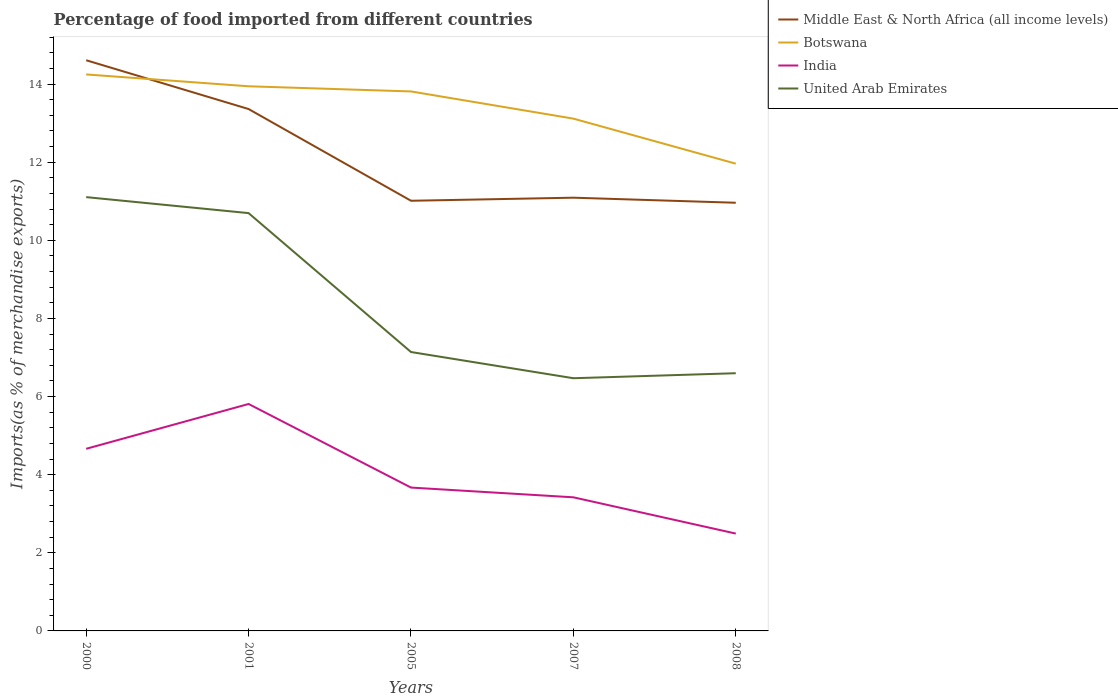How many different coloured lines are there?
Give a very brief answer. 4. Is the number of lines equal to the number of legend labels?
Keep it short and to the point. Yes. Across all years, what is the maximum percentage of imports to different countries in Middle East & North Africa (all income levels)?
Provide a short and direct response. 10.96. What is the total percentage of imports to different countries in Middle East & North Africa (all income levels) in the graph?
Ensure brevity in your answer.  1.25. What is the difference between the highest and the second highest percentage of imports to different countries in Middle East & North Africa (all income levels)?
Make the answer very short. 3.65. Is the percentage of imports to different countries in India strictly greater than the percentage of imports to different countries in Middle East & North Africa (all income levels) over the years?
Provide a succinct answer. Yes. How many years are there in the graph?
Keep it short and to the point. 5. What is the difference between two consecutive major ticks on the Y-axis?
Give a very brief answer. 2. Are the values on the major ticks of Y-axis written in scientific E-notation?
Your answer should be compact. No. Does the graph contain any zero values?
Give a very brief answer. No. Where does the legend appear in the graph?
Your response must be concise. Top right. What is the title of the graph?
Keep it short and to the point. Percentage of food imported from different countries. What is the label or title of the X-axis?
Your answer should be very brief. Years. What is the label or title of the Y-axis?
Make the answer very short. Imports(as % of merchandise exports). What is the Imports(as % of merchandise exports) in Middle East & North Africa (all income levels) in 2000?
Your answer should be compact. 14.61. What is the Imports(as % of merchandise exports) of Botswana in 2000?
Your answer should be very brief. 14.25. What is the Imports(as % of merchandise exports) of India in 2000?
Make the answer very short. 4.66. What is the Imports(as % of merchandise exports) of United Arab Emirates in 2000?
Your response must be concise. 11.11. What is the Imports(as % of merchandise exports) of Middle East & North Africa (all income levels) in 2001?
Ensure brevity in your answer.  13.36. What is the Imports(as % of merchandise exports) in Botswana in 2001?
Keep it short and to the point. 13.94. What is the Imports(as % of merchandise exports) in India in 2001?
Your answer should be very brief. 5.81. What is the Imports(as % of merchandise exports) in United Arab Emirates in 2001?
Provide a short and direct response. 10.7. What is the Imports(as % of merchandise exports) of Middle East & North Africa (all income levels) in 2005?
Make the answer very short. 11.01. What is the Imports(as % of merchandise exports) of Botswana in 2005?
Keep it short and to the point. 13.81. What is the Imports(as % of merchandise exports) in India in 2005?
Make the answer very short. 3.67. What is the Imports(as % of merchandise exports) in United Arab Emirates in 2005?
Your answer should be compact. 7.14. What is the Imports(as % of merchandise exports) in Middle East & North Africa (all income levels) in 2007?
Your answer should be very brief. 11.09. What is the Imports(as % of merchandise exports) in Botswana in 2007?
Keep it short and to the point. 13.12. What is the Imports(as % of merchandise exports) of India in 2007?
Make the answer very short. 3.42. What is the Imports(as % of merchandise exports) in United Arab Emirates in 2007?
Offer a terse response. 6.47. What is the Imports(as % of merchandise exports) in Middle East & North Africa (all income levels) in 2008?
Provide a succinct answer. 10.96. What is the Imports(as % of merchandise exports) of Botswana in 2008?
Make the answer very short. 11.96. What is the Imports(as % of merchandise exports) in India in 2008?
Ensure brevity in your answer.  2.49. What is the Imports(as % of merchandise exports) of United Arab Emirates in 2008?
Give a very brief answer. 6.6. Across all years, what is the maximum Imports(as % of merchandise exports) of Middle East & North Africa (all income levels)?
Your answer should be very brief. 14.61. Across all years, what is the maximum Imports(as % of merchandise exports) of Botswana?
Provide a succinct answer. 14.25. Across all years, what is the maximum Imports(as % of merchandise exports) of India?
Your answer should be very brief. 5.81. Across all years, what is the maximum Imports(as % of merchandise exports) of United Arab Emirates?
Your answer should be very brief. 11.11. Across all years, what is the minimum Imports(as % of merchandise exports) in Middle East & North Africa (all income levels)?
Your answer should be very brief. 10.96. Across all years, what is the minimum Imports(as % of merchandise exports) in Botswana?
Offer a very short reply. 11.96. Across all years, what is the minimum Imports(as % of merchandise exports) of India?
Ensure brevity in your answer.  2.49. Across all years, what is the minimum Imports(as % of merchandise exports) of United Arab Emirates?
Your answer should be compact. 6.47. What is the total Imports(as % of merchandise exports) of Middle East & North Africa (all income levels) in the graph?
Provide a succinct answer. 61.04. What is the total Imports(as % of merchandise exports) in Botswana in the graph?
Your answer should be compact. 67.08. What is the total Imports(as % of merchandise exports) in India in the graph?
Provide a succinct answer. 20.06. What is the total Imports(as % of merchandise exports) of United Arab Emirates in the graph?
Give a very brief answer. 42.01. What is the difference between the Imports(as % of merchandise exports) in Middle East & North Africa (all income levels) in 2000 and that in 2001?
Ensure brevity in your answer.  1.25. What is the difference between the Imports(as % of merchandise exports) of Botswana in 2000 and that in 2001?
Keep it short and to the point. 0.3. What is the difference between the Imports(as % of merchandise exports) of India in 2000 and that in 2001?
Offer a very short reply. -1.15. What is the difference between the Imports(as % of merchandise exports) in United Arab Emirates in 2000 and that in 2001?
Keep it short and to the point. 0.41. What is the difference between the Imports(as % of merchandise exports) in Middle East & North Africa (all income levels) in 2000 and that in 2005?
Offer a terse response. 3.6. What is the difference between the Imports(as % of merchandise exports) of Botswana in 2000 and that in 2005?
Provide a short and direct response. 0.44. What is the difference between the Imports(as % of merchandise exports) of India in 2000 and that in 2005?
Provide a succinct answer. 0.99. What is the difference between the Imports(as % of merchandise exports) in United Arab Emirates in 2000 and that in 2005?
Keep it short and to the point. 3.97. What is the difference between the Imports(as % of merchandise exports) of Middle East & North Africa (all income levels) in 2000 and that in 2007?
Your response must be concise. 3.52. What is the difference between the Imports(as % of merchandise exports) in Botswana in 2000 and that in 2007?
Your answer should be very brief. 1.13. What is the difference between the Imports(as % of merchandise exports) in India in 2000 and that in 2007?
Give a very brief answer. 1.24. What is the difference between the Imports(as % of merchandise exports) in United Arab Emirates in 2000 and that in 2007?
Give a very brief answer. 4.64. What is the difference between the Imports(as % of merchandise exports) in Middle East & North Africa (all income levels) in 2000 and that in 2008?
Offer a terse response. 3.65. What is the difference between the Imports(as % of merchandise exports) of Botswana in 2000 and that in 2008?
Your answer should be compact. 2.28. What is the difference between the Imports(as % of merchandise exports) in India in 2000 and that in 2008?
Your answer should be very brief. 2.17. What is the difference between the Imports(as % of merchandise exports) in United Arab Emirates in 2000 and that in 2008?
Offer a very short reply. 4.51. What is the difference between the Imports(as % of merchandise exports) of Middle East & North Africa (all income levels) in 2001 and that in 2005?
Keep it short and to the point. 2.35. What is the difference between the Imports(as % of merchandise exports) of Botswana in 2001 and that in 2005?
Give a very brief answer. 0.13. What is the difference between the Imports(as % of merchandise exports) of India in 2001 and that in 2005?
Offer a very short reply. 2.14. What is the difference between the Imports(as % of merchandise exports) in United Arab Emirates in 2001 and that in 2005?
Keep it short and to the point. 3.56. What is the difference between the Imports(as % of merchandise exports) in Middle East & North Africa (all income levels) in 2001 and that in 2007?
Your answer should be very brief. 2.27. What is the difference between the Imports(as % of merchandise exports) of Botswana in 2001 and that in 2007?
Keep it short and to the point. 0.83. What is the difference between the Imports(as % of merchandise exports) of India in 2001 and that in 2007?
Give a very brief answer. 2.39. What is the difference between the Imports(as % of merchandise exports) of United Arab Emirates in 2001 and that in 2007?
Make the answer very short. 4.23. What is the difference between the Imports(as % of merchandise exports) in Middle East & North Africa (all income levels) in 2001 and that in 2008?
Your answer should be very brief. 2.4. What is the difference between the Imports(as % of merchandise exports) of Botswana in 2001 and that in 2008?
Keep it short and to the point. 1.98. What is the difference between the Imports(as % of merchandise exports) in India in 2001 and that in 2008?
Provide a short and direct response. 3.32. What is the difference between the Imports(as % of merchandise exports) of United Arab Emirates in 2001 and that in 2008?
Your answer should be very brief. 4.1. What is the difference between the Imports(as % of merchandise exports) in Middle East & North Africa (all income levels) in 2005 and that in 2007?
Provide a succinct answer. -0.08. What is the difference between the Imports(as % of merchandise exports) of Botswana in 2005 and that in 2007?
Your answer should be very brief. 0.7. What is the difference between the Imports(as % of merchandise exports) of India in 2005 and that in 2007?
Make the answer very short. 0.25. What is the difference between the Imports(as % of merchandise exports) in United Arab Emirates in 2005 and that in 2007?
Ensure brevity in your answer.  0.67. What is the difference between the Imports(as % of merchandise exports) of Middle East & North Africa (all income levels) in 2005 and that in 2008?
Your answer should be compact. 0.05. What is the difference between the Imports(as % of merchandise exports) in Botswana in 2005 and that in 2008?
Offer a very short reply. 1.85. What is the difference between the Imports(as % of merchandise exports) of India in 2005 and that in 2008?
Give a very brief answer. 1.18. What is the difference between the Imports(as % of merchandise exports) in United Arab Emirates in 2005 and that in 2008?
Provide a succinct answer. 0.54. What is the difference between the Imports(as % of merchandise exports) of Middle East & North Africa (all income levels) in 2007 and that in 2008?
Your response must be concise. 0.13. What is the difference between the Imports(as % of merchandise exports) of Botswana in 2007 and that in 2008?
Provide a succinct answer. 1.15. What is the difference between the Imports(as % of merchandise exports) in India in 2007 and that in 2008?
Make the answer very short. 0.93. What is the difference between the Imports(as % of merchandise exports) in United Arab Emirates in 2007 and that in 2008?
Your answer should be very brief. -0.13. What is the difference between the Imports(as % of merchandise exports) of Middle East & North Africa (all income levels) in 2000 and the Imports(as % of merchandise exports) of Botswana in 2001?
Your response must be concise. 0.67. What is the difference between the Imports(as % of merchandise exports) of Middle East & North Africa (all income levels) in 2000 and the Imports(as % of merchandise exports) of India in 2001?
Make the answer very short. 8.8. What is the difference between the Imports(as % of merchandise exports) in Middle East & North Africa (all income levels) in 2000 and the Imports(as % of merchandise exports) in United Arab Emirates in 2001?
Your answer should be compact. 3.91. What is the difference between the Imports(as % of merchandise exports) of Botswana in 2000 and the Imports(as % of merchandise exports) of India in 2001?
Ensure brevity in your answer.  8.44. What is the difference between the Imports(as % of merchandise exports) of Botswana in 2000 and the Imports(as % of merchandise exports) of United Arab Emirates in 2001?
Keep it short and to the point. 3.55. What is the difference between the Imports(as % of merchandise exports) of India in 2000 and the Imports(as % of merchandise exports) of United Arab Emirates in 2001?
Offer a terse response. -6.03. What is the difference between the Imports(as % of merchandise exports) in Middle East & North Africa (all income levels) in 2000 and the Imports(as % of merchandise exports) in Botswana in 2005?
Give a very brief answer. 0.8. What is the difference between the Imports(as % of merchandise exports) in Middle East & North Africa (all income levels) in 2000 and the Imports(as % of merchandise exports) in India in 2005?
Your answer should be very brief. 10.94. What is the difference between the Imports(as % of merchandise exports) of Middle East & North Africa (all income levels) in 2000 and the Imports(as % of merchandise exports) of United Arab Emirates in 2005?
Offer a very short reply. 7.47. What is the difference between the Imports(as % of merchandise exports) in Botswana in 2000 and the Imports(as % of merchandise exports) in India in 2005?
Offer a terse response. 10.58. What is the difference between the Imports(as % of merchandise exports) in Botswana in 2000 and the Imports(as % of merchandise exports) in United Arab Emirates in 2005?
Your answer should be very brief. 7.11. What is the difference between the Imports(as % of merchandise exports) in India in 2000 and the Imports(as % of merchandise exports) in United Arab Emirates in 2005?
Offer a terse response. -2.48. What is the difference between the Imports(as % of merchandise exports) in Middle East & North Africa (all income levels) in 2000 and the Imports(as % of merchandise exports) in Botswana in 2007?
Make the answer very short. 1.49. What is the difference between the Imports(as % of merchandise exports) in Middle East & North Africa (all income levels) in 2000 and the Imports(as % of merchandise exports) in India in 2007?
Your answer should be very brief. 11.19. What is the difference between the Imports(as % of merchandise exports) in Middle East & North Africa (all income levels) in 2000 and the Imports(as % of merchandise exports) in United Arab Emirates in 2007?
Provide a succinct answer. 8.14. What is the difference between the Imports(as % of merchandise exports) in Botswana in 2000 and the Imports(as % of merchandise exports) in India in 2007?
Make the answer very short. 10.83. What is the difference between the Imports(as % of merchandise exports) of Botswana in 2000 and the Imports(as % of merchandise exports) of United Arab Emirates in 2007?
Your response must be concise. 7.78. What is the difference between the Imports(as % of merchandise exports) of India in 2000 and the Imports(as % of merchandise exports) of United Arab Emirates in 2007?
Provide a succinct answer. -1.81. What is the difference between the Imports(as % of merchandise exports) of Middle East & North Africa (all income levels) in 2000 and the Imports(as % of merchandise exports) of Botswana in 2008?
Make the answer very short. 2.65. What is the difference between the Imports(as % of merchandise exports) in Middle East & North Africa (all income levels) in 2000 and the Imports(as % of merchandise exports) in India in 2008?
Keep it short and to the point. 12.12. What is the difference between the Imports(as % of merchandise exports) in Middle East & North Africa (all income levels) in 2000 and the Imports(as % of merchandise exports) in United Arab Emirates in 2008?
Offer a very short reply. 8.01. What is the difference between the Imports(as % of merchandise exports) in Botswana in 2000 and the Imports(as % of merchandise exports) in India in 2008?
Your response must be concise. 11.75. What is the difference between the Imports(as % of merchandise exports) of Botswana in 2000 and the Imports(as % of merchandise exports) of United Arab Emirates in 2008?
Give a very brief answer. 7.65. What is the difference between the Imports(as % of merchandise exports) of India in 2000 and the Imports(as % of merchandise exports) of United Arab Emirates in 2008?
Provide a short and direct response. -1.93. What is the difference between the Imports(as % of merchandise exports) of Middle East & North Africa (all income levels) in 2001 and the Imports(as % of merchandise exports) of Botswana in 2005?
Keep it short and to the point. -0.45. What is the difference between the Imports(as % of merchandise exports) of Middle East & North Africa (all income levels) in 2001 and the Imports(as % of merchandise exports) of India in 2005?
Your answer should be compact. 9.69. What is the difference between the Imports(as % of merchandise exports) in Middle East & North Africa (all income levels) in 2001 and the Imports(as % of merchandise exports) in United Arab Emirates in 2005?
Offer a terse response. 6.22. What is the difference between the Imports(as % of merchandise exports) in Botswana in 2001 and the Imports(as % of merchandise exports) in India in 2005?
Your answer should be very brief. 10.27. What is the difference between the Imports(as % of merchandise exports) in Botswana in 2001 and the Imports(as % of merchandise exports) in United Arab Emirates in 2005?
Keep it short and to the point. 6.8. What is the difference between the Imports(as % of merchandise exports) in India in 2001 and the Imports(as % of merchandise exports) in United Arab Emirates in 2005?
Your response must be concise. -1.33. What is the difference between the Imports(as % of merchandise exports) of Middle East & North Africa (all income levels) in 2001 and the Imports(as % of merchandise exports) of Botswana in 2007?
Offer a terse response. 0.25. What is the difference between the Imports(as % of merchandise exports) in Middle East & North Africa (all income levels) in 2001 and the Imports(as % of merchandise exports) in India in 2007?
Give a very brief answer. 9.94. What is the difference between the Imports(as % of merchandise exports) of Middle East & North Africa (all income levels) in 2001 and the Imports(as % of merchandise exports) of United Arab Emirates in 2007?
Keep it short and to the point. 6.89. What is the difference between the Imports(as % of merchandise exports) in Botswana in 2001 and the Imports(as % of merchandise exports) in India in 2007?
Provide a succinct answer. 10.52. What is the difference between the Imports(as % of merchandise exports) in Botswana in 2001 and the Imports(as % of merchandise exports) in United Arab Emirates in 2007?
Ensure brevity in your answer.  7.47. What is the difference between the Imports(as % of merchandise exports) in India in 2001 and the Imports(as % of merchandise exports) in United Arab Emirates in 2007?
Make the answer very short. -0.66. What is the difference between the Imports(as % of merchandise exports) in Middle East & North Africa (all income levels) in 2001 and the Imports(as % of merchandise exports) in Botswana in 2008?
Your answer should be compact. 1.4. What is the difference between the Imports(as % of merchandise exports) in Middle East & North Africa (all income levels) in 2001 and the Imports(as % of merchandise exports) in India in 2008?
Offer a terse response. 10.87. What is the difference between the Imports(as % of merchandise exports) in Middle East & North Africa (all income levels) in 2001 and the Imports(as % of merchandise exports) in United Arab Emirates in 2008?
Your answer should be very brief. 6.76. What is the difference between the Imports(as % of merchandise exports) of Botswana in 2001 and the Imports(as % of merchandise exports) of India in 2008?
Provide a succinct answer. 11.45. What is the difference between the Imports(as % of merchandise exports) of Botswana in 2001 and the Imports(as % of merchandise exports) of United Arab Emirates in 2008?
Offer a terse response. 7.35. What is the difference between the Imports(as % of merchandise exports) of India in 2001 and the Imports(as % of merchandise exports) of United Arab Emirates in 2008?
Offer a terse response. -0.79. What is the difference between the Imports(as % of merchandise exports) of Middle East & North Africa (all income levels) in 2005 and the Imports(as % of merchandise exports) of Botswana in 2007?
Give a very brief answer. -2.1. What is the difference between the Imports(as % of merchandise exports) in Middle East & North Africa (all income levels) in 2005 and the Imports(as % of merchandise exports) in India in 2007?
Ensure brevity in your answer.  7.59. What is the difference between the Imports(as % of merchandise exports) of Middle East & North Africa (all income levels) in 2005 and the Imports(as % of merchandise exports) of United Arab Emirates in 2007?
Your response must be concise. 4.54. What is the difference between the Imports(as % of merchandise exports) in Botswana in 2005 and the Imports(as % of merchandise exports) in India in 2007?
Provide a succinct answer. 10.39. What is the difference between the Imports(as % of merchandise exports) in Botswana in 2005 and the Imports(as % of merchandise exports) in United Arab Emirates in 2007?
Make the answer very short. 7.34. What is the difference between the Imports(as % of merchandise exports) of India in 2005 and the Imports(as % of merchandise exports) of United Arab Emirates in 2007?
Ensure brevity in your answer.  -2.8. What is the difference between the Imports(as % of merchandise exports) of Middle East & North Africa (all income levels) in 2005 and the Imports(as % of merchandise exports) of Botswana in 2008?
Your answer should be very brief. -0.95. What is the difference between the Imports(as % of merchandise exports) in Middle East & North Africa (all income levels) in 2005 and the Imports(as % of merchandise exports) in India in 2008?
Offer a terse response. 8.52. What is the difference between the Imports(as % of merchandise exports) in Middle East & North Africa (all income levels) in 2005 and the Imports(as % of merchandise exports) in United Arab Emirates in 2008?
Your answer should be very brief. 4.42. What is the difference between the Imports(as % of merchandise exports) of Botswana in 2005 and the Imports(as % of merchandise exports) of India in 2008?
Give a very brief answer. 11.32. What is the difference between the Imports(as % of merchandise exports) in Botswana in 2005 and the Imports(as % of merchandise exports) in United Arab Emirates in 2008?
Give a very brief answer. 7.21. What is the difference between the Imports(as % of merchandise exports) in India in 2005 and the Imports(as % of merchandise exports) in United Arab Emirates in 2008?
Make the answer very short. -2.93. What is the difference between the Imports(as % of merchandise exports) of Middle East & North Africa (all income levels) in 2007 and the Imports(as % of merchandise exports) of Botswana in 2008?
Make the answer very short. -0.87. What is the difference between the Imports(as % of merchandise exports) in Middle East & North Africa (all income levels) in 2007 and the Imports(as % of merchandise exports) in India in 2008?
Keep it short and to the point. 8.6. What is the difference between the Imports(as % of merchandise exports) in Middle East & North Africa (all income levels) in 2007 and the Imports(as % of merchandise exports) in United Arab Emirates in 2008?
Make the answer very short. 4.49. What is the difference between the Imports(as % of merchandise exports) of Botswana in 2007 and the Imports(as % of merchandise exports) of India in 2008?
Make the answer very short. 10.62. What is the difference between the Imports(as % of merchandise exports) of Botswana in 2007 and the Imports(as % of merchandise exports) of United Arab Emirates in 2008?
Your answer should be compact. 6.52. What is the difference between the Imports(as % of merchandise exports) in India in 2007 and the Imports(as % of merchandise exports) in United Arab Emirates in 2008?
Provide a succinct answer. -3.18. What is the average Imports(as % of merchandise exports) in Middle East & North Africa (all income levels) per year?
Your answer should be compact. 12.21. What is the average Imports(as % of merchandise exports) of Botswana per year?
Provide a succinct answer. 13.42. What is the average Imports(as % of merchandise exports) of India per year?
Keep it short and to the point. 4.01. What is the average Imports(as % of merchandise exports) in United Arab Emirates per year?
Ensure brevity in your answer.  8.4. In the year 2000, what is the difference between the Imports(as % of merchandise exports) in Middle East & North Africa (all income levels) and Imports(as % of merchandise exports) in Botswana?
Make the answer very short. 0.36. In the year 2000, what is the difference between the Imports(as % of merchandise exports) in Middle East & North Africa (all income levels) and Imports(as % of merchandise exports) in India?
Offer a terse response. 9.95. In the year 2000, what is the difference between the Imports(as % of merchandise exports) in Middle East & North Africa (all income levels) and Imports(as % of merchandise exports) in United Arab Emirates?
Your answer should be very brief. 3.5. In the year 2000, what is the difference between the Imports(as % of merchandise exports) in Botswana and Imports(as % of merchandise exports) in India?
Offer a very short reply. 9.58. In the year 2000, what is the difference between the Imports(as % of merchandise exports) of Botswana and Imports(as % of merchandise exports) of United Arab Emirates?
Make the answer very short. 3.14. In the year 2000, what is the difference between the Imports(as % of merchandise exports) of India and Imports(as % of merchandise exports) of United Arab Emirates?
Your response must be concise. -6.44. In the year 2001, what is the difference between the Imports(as % of merchandise exports) in Middle East & North Africa (all income levels) and Imports(as % of merchandise exports) in Botswana?
Your answer should be very brief. -0.58. In the year 2001, what is the difference between the Imports(as % of merchandise exports) in Middle East & North Africa (all income levels) and Imports(as % of merchandise exports) in India?
Ensure brevity in your answer.  7.55. In the year 2001, what is the difference between the Imports(as % of merchandise exports) in Middle East & North Africa (all income levels) and Imports(as % of merchandise exports) in United Arab Emirates?
Your answer should be compact. 2.66. In the year 2001, what is the difference between the Imports(as % of merchandise exports) in Botswana and Imports(as % of merchandise exports) in India?
Provide a short and direct response. 8.13. In the year 2001, what is the difference between the Imports(as % of merchandise exports) of Botswana and Imports(as % of merchandise exports) of United Arab Emirates?
Your response must be concise. 3.25. In the year 2001, what is the difference between the Imports(as % of merchandise exports) of India and Imports(as % of merchandise exports) of United Arab Emirates?
Offer a terse response. -4.89. In the year 2005, what is the difference between the Imports(as % of merchandise exports) in Middle East & North Africa (all income levels) and Imports(as % of merchandise exports) in Botswana?
Give a very brief answer. -2.8. In the year 2005, what is the difference between the Imports(as % of merchandise exports) in Middle East & North Africa (all income levels) and Imports(as % of merchandise exports) in India?
Give a very brief answer. 7.34. In the year 2005, what is the difference between the Imports(as % of merchandise exports) of Middle East & North Africa (all income levels) and Imports(as % of merchandise exports) of United Arab Emirates?
Your response must be concise. 3.87. In the year 2005, what is the difference between the Imports(as % of merchandise exports) in Botswana and Imports(as % of merchandise exports) in India?
Your response must be concise. 10.14. In the year 2005, what is the difference between the Imports(as % of merchandise exports) in Botswana and Imports(as % of merchandise exports) in United Arab Emirates?
Your answer should be compact. 6.67. In the year 2005, what is the difference between the Imports(as % of merchandise exports) of India and Imports(as % of merchandise exports) of United Arab Emirates?
Your answer should be compact. -3.47. In the year 2007, what is the difference between the Imports(as % of merchandise exports) in Middle East & North Africa (all income levels) and Imports(as % of merchandise exports) in Botswana?
Provide a succinct answer. -2.02. In the year 2007, what is the difference between the Imports(as % of merchandise exports) of Middle East & North Africa (all income levels) and Imports(as % of merchandise exports) of India?
Your response must be concise. 7.67. In the year 2007, what is the difference between the Imports(as % of merchandise exports) in Middle East & North Africa (all income levels) and Imports(as % of merchandise exports) in United Arab Emirates?
Offer a very short reply. 4.62. In the year 2007, what is the difference between the Imports(as % of merchandise exports) of Botswana and Imports(as % of merchandise exports) of India?
Keep it short and to the point. 9.69. In the year 2007, what is the difference between the Imports(as % of merchandise exports) in Botswana and Imports(as % of merchandise exports) in United Arab Emirates?
Offer a very short reply. 6.65. In the year 2007, what is the difference between the Imports(as % of merchandise exports) in India and Imports(as % of merchandise exports) in United Arab Emirates?
Provide a succinct answer. -3.05. In the year 2008, what is the difference between the Imports(as % of merchandise exports) in Middle East & North Africa (all income levels) and Imports(as % of merchandise exports) in Botswana?
Your answer should be compact. -1. In the year 2008, what is the difference between the Imports(as % of merchandise exports) of Middle East & North Africa (all income levels) and Imports(as % of merchandise exports) of India?
Give a very brief answer. 8.47. In the year 2008, what is the difference between the Imports(as % of merchandise exports) of Middle East & North Africa (all income levels) and Imports(as % of merchandise exports) of United Arab Emirates?
Offer a terse response. 4.36. In the year 2008, what is the difference between the Imports(as % of merchandise exports) in Botswana and Imports(as % of merchandise exports) in India?
Offer a terse response. 9.47. In the year 2008, what is the difference between the Imports(as % of merchandise exports) in Botswana and Imports(as % of merchandise exports) in United Arab Emirates?
Give a very brief answer. 5.36. In the year 2008, what is the difference between the Imports(as % of merchandise exports) in India and Imports(as % of merchandise exports) in United Arab Emirates?
Your answer should be very brief. -4.11. What is the ratio of the Imports(as % of merchandise exports) of Middle East & North Africa (all income levels) in 2000 to that in 2001?
Give a very brief answer. 1.09. What is the ratio of the Imports(as % of merchandise exports) of Botswana in 2000 to that in 2001?
Make the answer very short. 1.02. What is the ratio of the Imports(as % of merchandise exports) in India in 2000 to that in 2001?
Provide a short and direct response. 0.8. What is the ratio of the Imports(as % of merchandise exports) of United Arab Emirates in 2000 to that in 2001?
Your answer should be compact. 1.04. What is the ratio of the Imports(as % of merchandise exports) of Middle East & North Africa (all income levels) in 2000 to that in 2005?
Ensure brevity in your answer.  1.33. What is the ratio of the Imports(as % of merchandise exports) in Botswana in 2000 to that in 2005?
Make the answer very short. 1.03. What is the ratio of the Imports(as % of merchandise exports) of India in 2000 to that in 2005?
Provide a short and direct response. 1.27. What is the ratio of the Imports(as % of merchandise exports) in United Arab Emirates in 2000 to that in 2005?
Make the answer very short. 1.56. What is the ratio of the Imports(as % of merchandise exports) in Middle East & North Africa (all income levels) in 2000 to that in 2007?
Your answer should be compact. 1.32. What is the ratio of the Imports(as % of merchandise exports) of Botswana in 2000 to that in 2007?
Offer a terse response. 1.09. What is the ratio of the Imports(as % of merchandise exports) in India in 2000 to that in 2007?
Give a very brief answer. 1.36. What is the ratio of the Imports(as % of merchandise exports) of United Arab Emirates in 2000 to that in 2007?
Provide a short and direct response. 1.72. What is the ratio of the Imports(as % of merchandise exports) in Middle East & North Africa (all income levels) in 2000 to that in 2008?
Your answer should be compact. 1.33. What is the ratio of the Imports(as % of merchandise exports) of Botswana in 2000 to that in 2008?
Offer a terse response. 1.19. What is the ratio of the Imports(as % of merchandise exports) of India in 2000 to that in 2008?
Your response must be concise. 1.87. What is the ratio of the Imports(as % of merchandise exports) in United Arab Emirates in 2000 to that in 2008?
Provide a succinct answer. 1.68. What is the ratio of the Imports(as % of merchandise exports) of Middle East & North Africa (all income levels) in 2001 to that in 2005?
Your response must be concise. 1.21. What is the ratio of the Imports(as % of merchandise exports) in Botswana in 2001 to that in 2005?
Your response must be concise. 1.01. What is the ratio of the Imports(as % of merchandise exports) of India in 2001 to that in 2005?
Offer a terse response. 1.58. What is the ratio of the Imports(as % of merchandise exports) in United Arab Emirates in 2001 to that in 2005?
Your answer should be very brief. 1.5. What is the ratio of the Imports(as % of merchandise exports) of Middle East & North Africa (all income levels) in 2001 to that in 2007?
Provide a short and direct response. 1.2. What is the ratio of the Imports(as % of merchandise exports) in Botswana in 2001 to that in 2007?
Ensure brevity in your answer.  1.06. What is the ratio of the Imports(as % of merchandise exports) of India in 2001 to that in 2007?
Give a very brief answer. 1.7. What is the ratio of the Imports(as % of merchandise exports) of United Arab Emirates in 2001 to that in 2007?
Ensure brevity in your answer.  1.65. What is the ratio of the Imports(as % of merchandise exports) in Middle East & North Africa (all income levels) in 2001 to that in 2008?
Provide a short and direct response. 1.22. What is the ratio of the Imports(as % of merchandise exports) in Botswana in 2001 to that in 2008?
Offer a very short reply. 1.17. What is the ratio of the Imports(as % of merchandise exports) in India in 2001 to that in 2008?
Make the answer very short. 2.33. What is the ratio of the Imports(as % of merchandise exports) in United Arab Emirates in 2001 to that in 2008?
Make the answer very short. 1.62. What is the ratio of the Imports(as % of merchandise exports) of Botswana in 2005 to that in 2007?
Your answer should be compact. 1.05. What is the ratio of the Imports(as % of merchandise exports) of India in 2005 to that in 2007?
Give a very brief answer. 1.07. What is the ratio of the Imports(as % of merchandise exports) of United Arab Emirates in 2005 to that in 2007?
Your answer should be very brief. 1.1. What is the ratio of the Imports(as % of merchandise exports) of Middle East & North Africa (all income levels) in 2005 to that in 2008?
Keep it short and to the point. 1. What is the ratio of the Imports(as % of merchandise exports) in Botswana in 2005 to that in 2008?
Give a very brief answer. 1.15. What is the ratio of the Imports(as % of merchandise exports) of India in 2005 to that in 2008?
Keep it short and to the point. 1.47. What is the ratio of the Imports(as % of merchandise exports) of United Arab Emirates in 2005 to that in 2008?
Offer a terse response. 1.08. What is the ratio of the Imports(as % of merchandise exports) in Middle East & North Africa (all income levels) in 2007 to that in 2008?
Give a very brief answer. 1.01. What is the ratio of the Imports(as % of merchandise exports) in Botswana in 2007 to that in 2008?
Give a very brief answer. 1.1. What is the ratio of the Imports(as % of merchandise exports) of India in 2007 to that in 2008?
Offer a very short reply. 1.37. What is the ratio of the Imports(as % of merchandise exports) of United Arab Emirates in 2007 to that in 2008?
Give a very brief answer. 0.98. What is the difference between the highest and the second highest Imports(as % of merchandise exports) in Middle East & North Africa (all income levels)?
Give a very brief answer. 1.25. What is the difference between the highest and the second highest Imports(as % of merchandise exports) of Botswana?
Your answer should be very brief. 0.3. What is the difference between the highest and the second highest Imports(as % of merchandise exports) in India?
Offer a terse response. 1.15. What is the difference between the highest and the second highest Imports(as % of merchandise exports) of United Arab Emirates?
Offer a terse response. 0.41. What is the difference between the highest and the lowest Imports(as % of merchandise exports) in Middle East & North Africa (all income levels)?
Your response must be concise. 3.65. What is the difference between the highest and the lowest Imports(as % of merchandise exports) in Botswana?
Your answer should be very brief. 2.28. What is the difference between the highest and the lowest Imports(as % of merchandise exports) in India?
Provide a short and direct response. 3.32. What is the difference between the highest and the lowest Imports(as % of merchandise exports) in United Arab Emirates?
Ensure brevity in your answer.  4.64. 